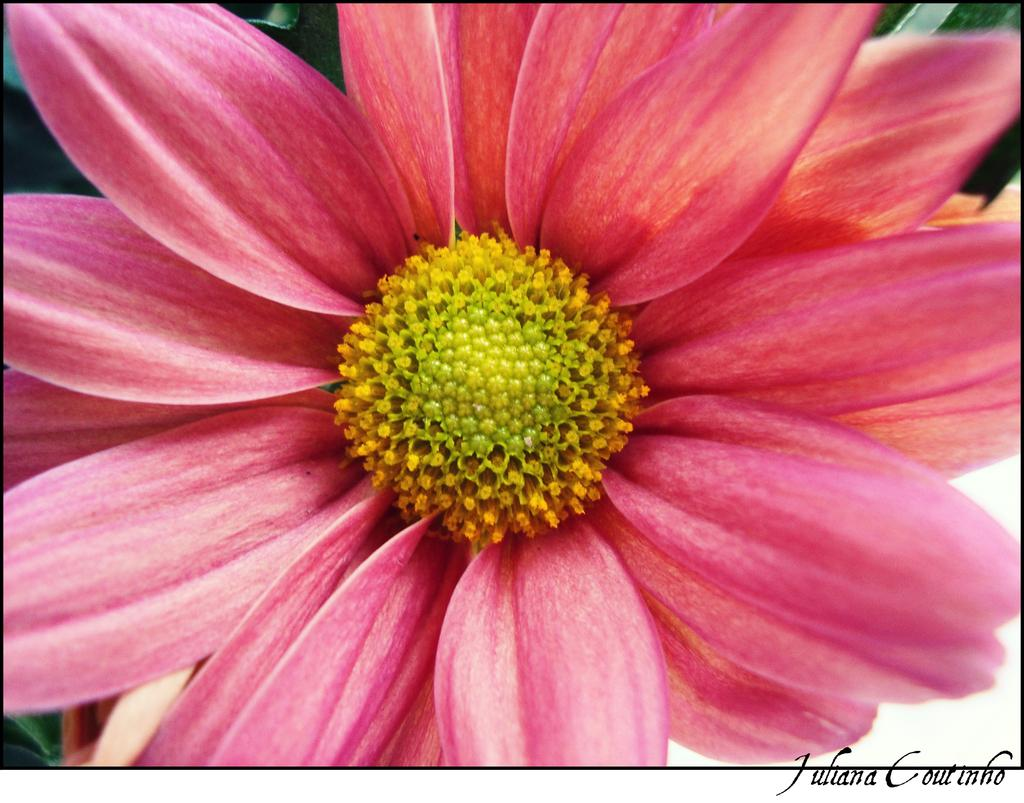What type of flower is in the image? There is a pink flower in the image. What color is the center of the flower? The center of the flower is yellow in color. Is there any text or label in the image? Yes, there is a name at the bottom of the image. Where is the stove located in the image? There is no stove present in the image. What type of plantation is shown in the image? The image does not depict a plantation; it features a pink flower with a yellow center. 